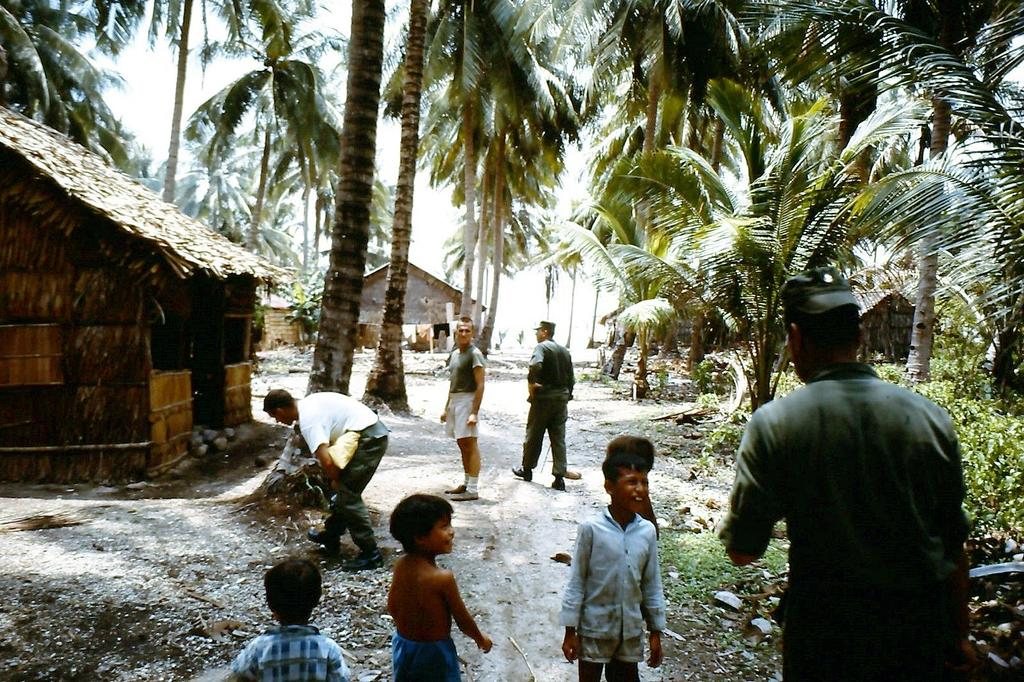How many children are in the image? There are kids in the image, but the exact number is not specified. What else can be seen in the image besides the kids? There are four men, tall trees, plants, and two huts in the image. Can you describe the vegetation in the image? There are tall trees and plants in the image. How many huts are present in the image? There are two huts in the image. What type of celery is being used as a game prop in the image? There is no celery or game present in the image. What statement is being made by the kids in the image? The image does not depict any statements being made by the kids. 